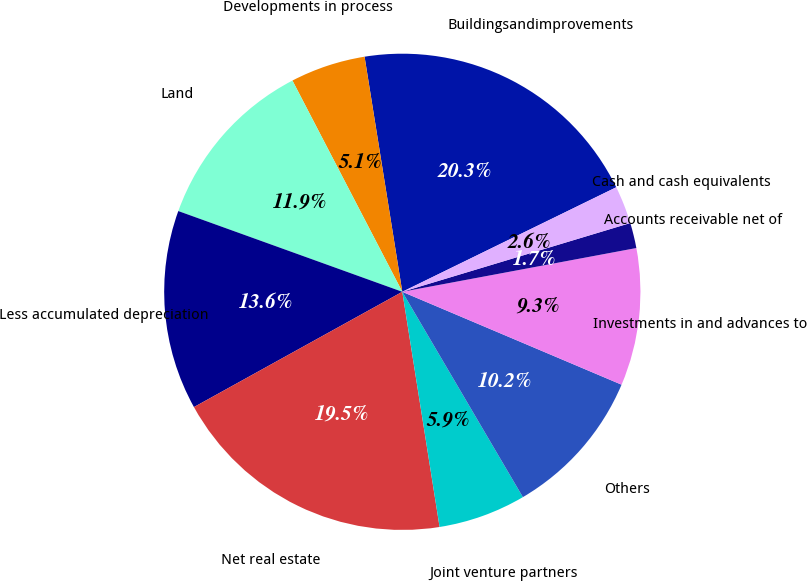Convert chart to OTSL. <chart><loc_0><loc_0><loc_500><loc_500><pie_chart><fcel>Buildingsandimprovements<fcel>Developments in process<fcel>Land<fcel>Less accumulated depreciation<fcel>Net real estate<fcel>Joint venture partners<fcel>Others<fcel>Investments in and advances to<fcel>Accounts receivable net of<fcel>Cash and cash equivalents<nl><fcel>20.3%<fcel>5.1%<fcel>11.86%<fcel>13.55%<fcel>19.46%<fcel>5.95%<fcel>10.17%<fcel>9.32%<fcel>1.72%<fcel>2.57%<nl></chart> 